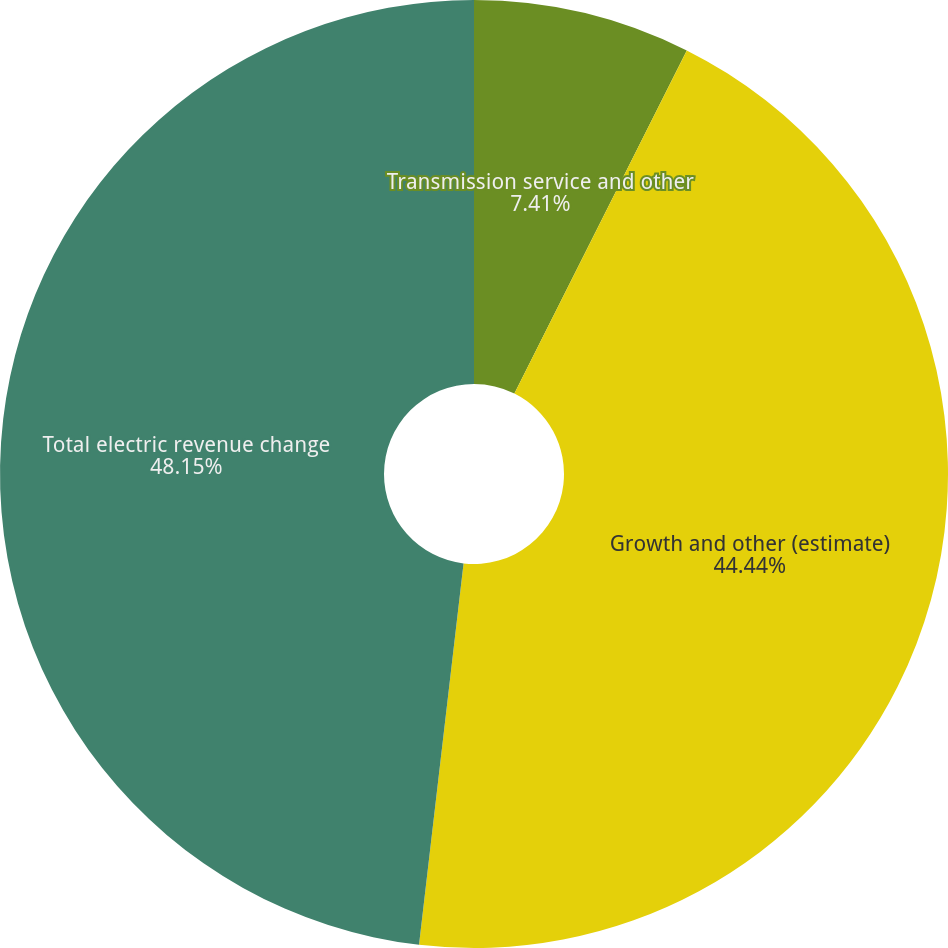Convert chart. <chart><loc_0><loc_0><loc_500><loc_500><pie_chart><fcel>Transmission service and other<fcel>Growth and other (estimate)<fcel>Total electric revenue change<nl><fcel>7.41%<fcel>44.44%<fcel>48.15%<nl></chart> 